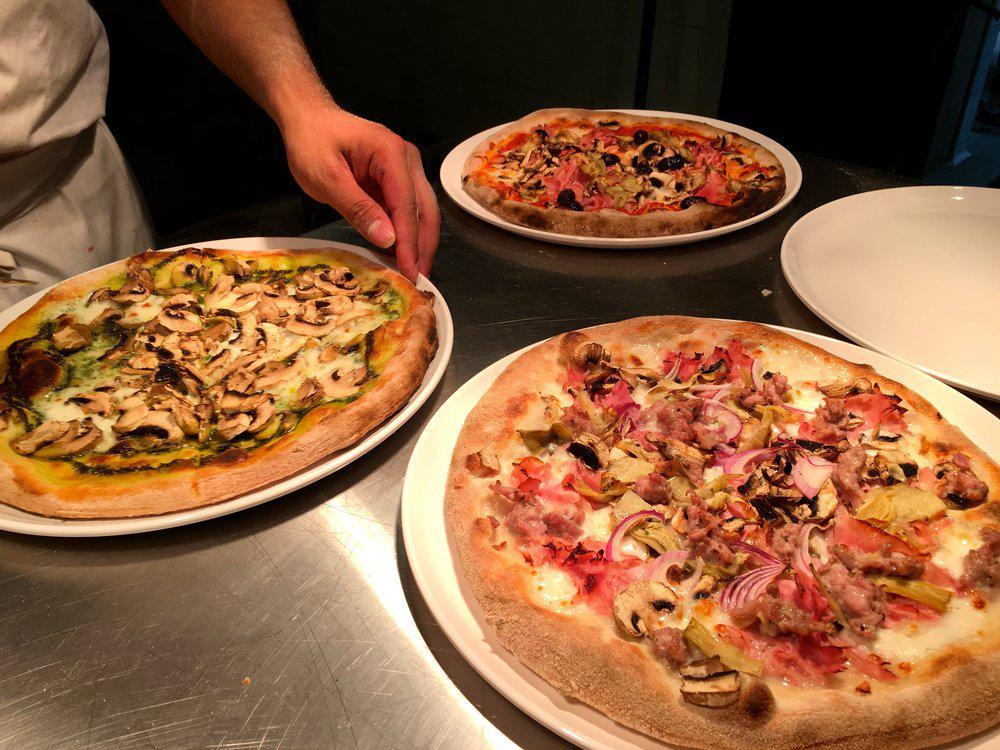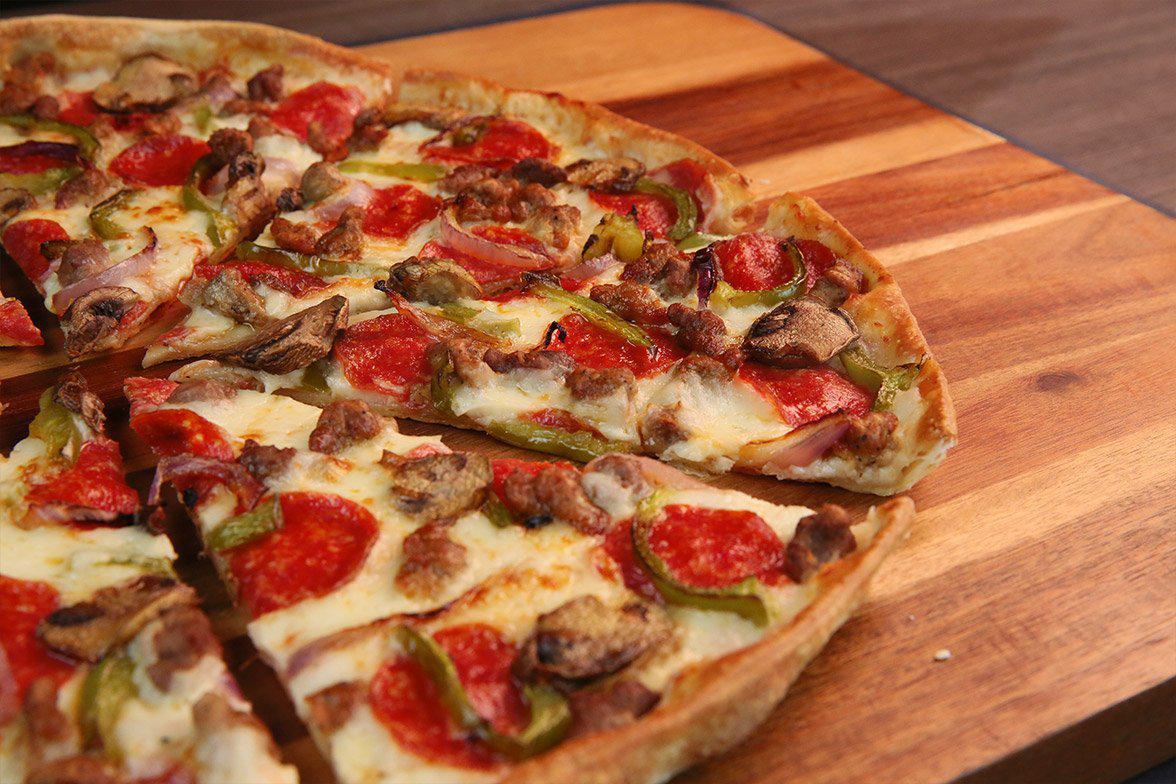The first image is the image on the left, the second image is the image on the right. Given the left and right images, does the statement "There are more pizzas in the image on the right." hold true? Answer yes or no. No. The first image is the image on the left, the second image is the image on the right. For the images shown, is this caption "The left image contains one pizza on a round wooden tray, which has at least one slice out of place." true? Answer yes or no. No. 